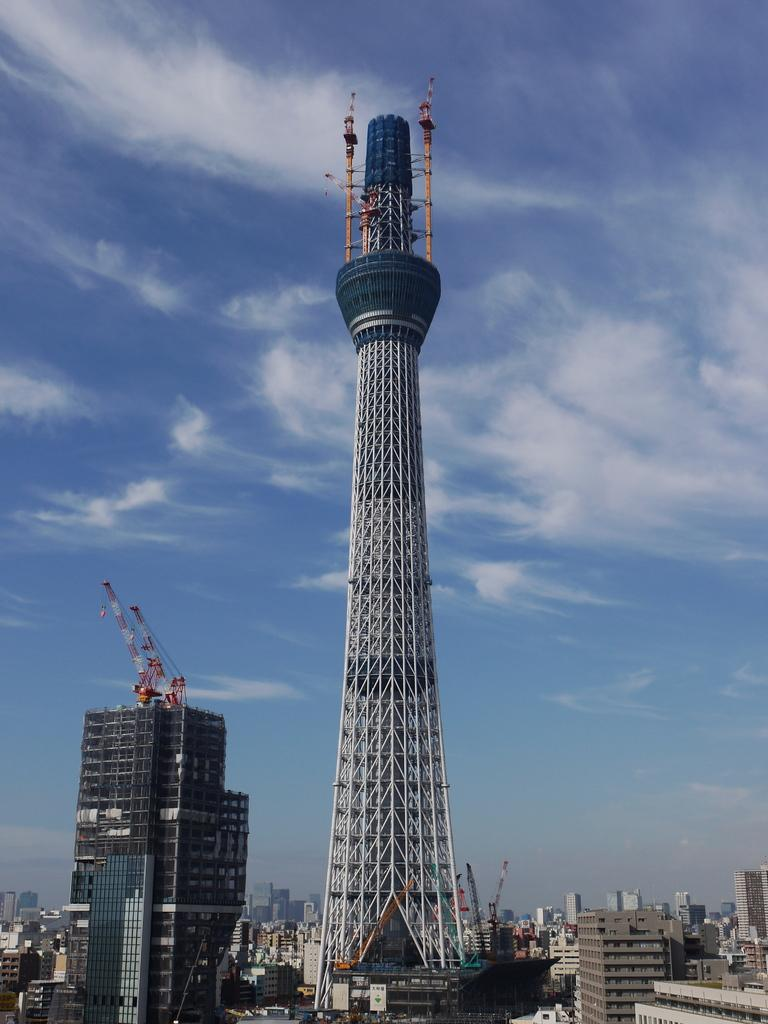What type of structures can be seen in the image? There are multiple buildings in the image, including a huge tower. What can be found on top of some of the buildings? There are cranes on the buildings, which are red and white in color. What is visible in the background of the image? The sky is visible in the background of the image. What type of quilt is being used to cover the news in the image? There is no quilt or news present in the image; it features multiple buildings, a huge tower, and red and white cranes. How many people are walking in the image? There is no indication of people walking in the image; it focuses on the buildings, tower, and cranes. 